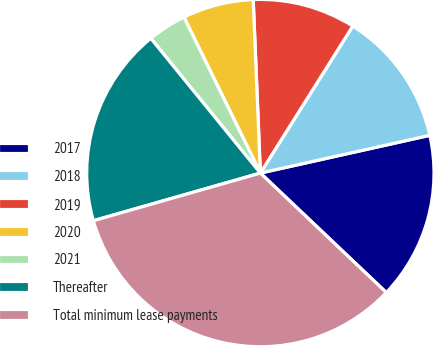<chart> <loc_0><loc_0><loc_500><loc_500><pie_chart><fcel>2017<fcel>2018<fcel>2019<fcel>2020<fcel>2021<fcel>Thereafter<fcel>Total minimum lease payments<nl><fcel>15.57%<fcel>12.58%<fcel>9.59%<fcel>6.6%<fcel>3.61%<fcel>18.56%<fcel>33.5%<nl></chart> 